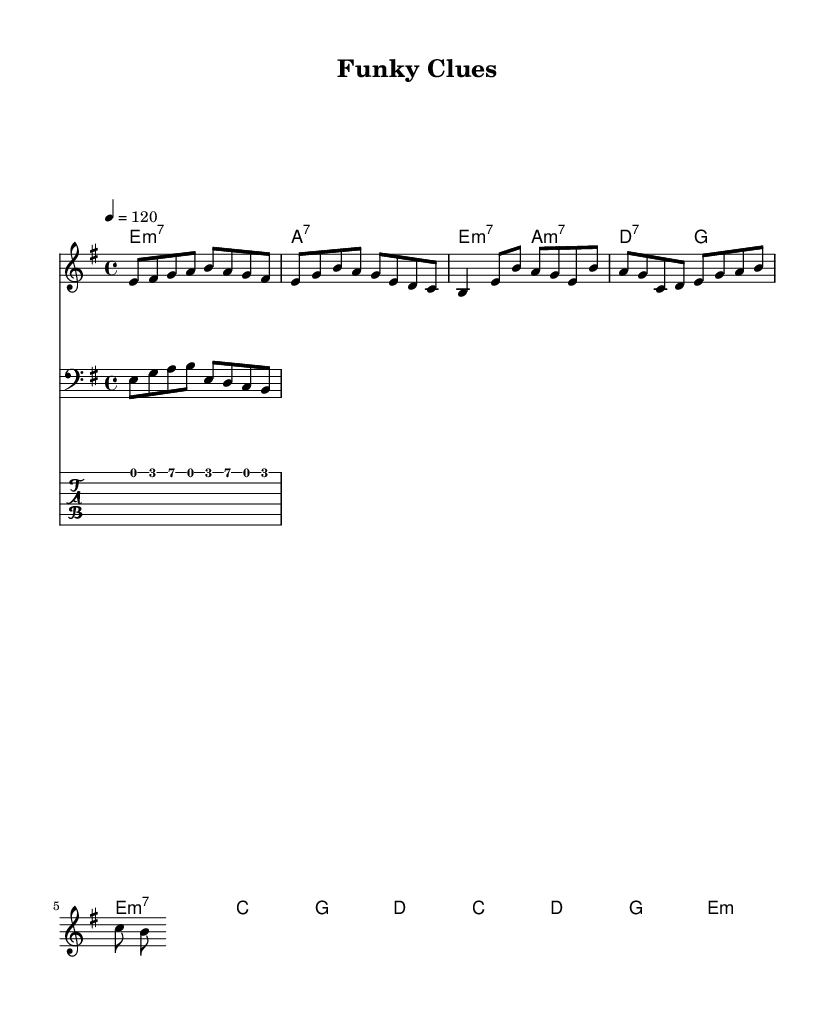What is the key signature of this music? The key signature is E minor, indicated by one sharp (F#). Since the sheet music states "e" as the key, we can confirm it is E minor.
Answer: E minor What is the time signature of this music? The time signature is 4/4, as shown in the notation. This means there are four beats in each measure, and each quarter note gets one beat.
Answer: 4/4 What is the tempo marking of this music? The tempo marking is 120 beats per minute, specified in the score. This tells musicians to play at a moderate speed, specifically 120 quarter notes per minute.
Answer: 120 How many measures are in the chorus section? The chorus section contains four measures, as indicated by the grouping of notes and rests shown in that section of the sheet music.
Answer: 4 What type of chord is used in the intro? The chords used in the intro are E minor 7 and A dominant 7, characterized by their respective notations in the harmonic section.
Answer: E minor 7 and A dominant 7 Are there any syncopated rhythms observable in this music? Yes, syncopation can be observed particularly in the bass line and guitar riff sections where the accents shift onto the offbeats, contributing to the funk feel.
Answer: Yes What is the main theme conveyed by the melody in the verse? The main theme of the melody in the verse revolves around a melodic descent, creating a mysterious and funky vibe, emphasizing secrecy suitable for the 'Funky Clues' concept.
Answer: Descent 